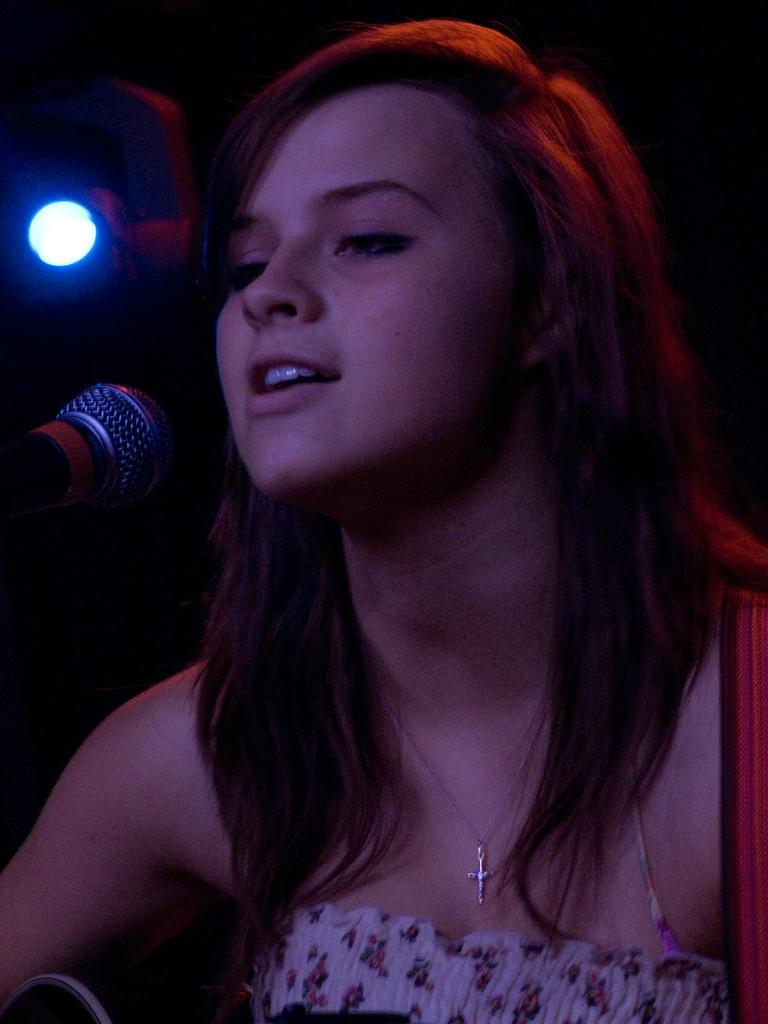Can you describe this image briefly? There is a woman singing in front of a mic and there is a light behind her in the left corner. 